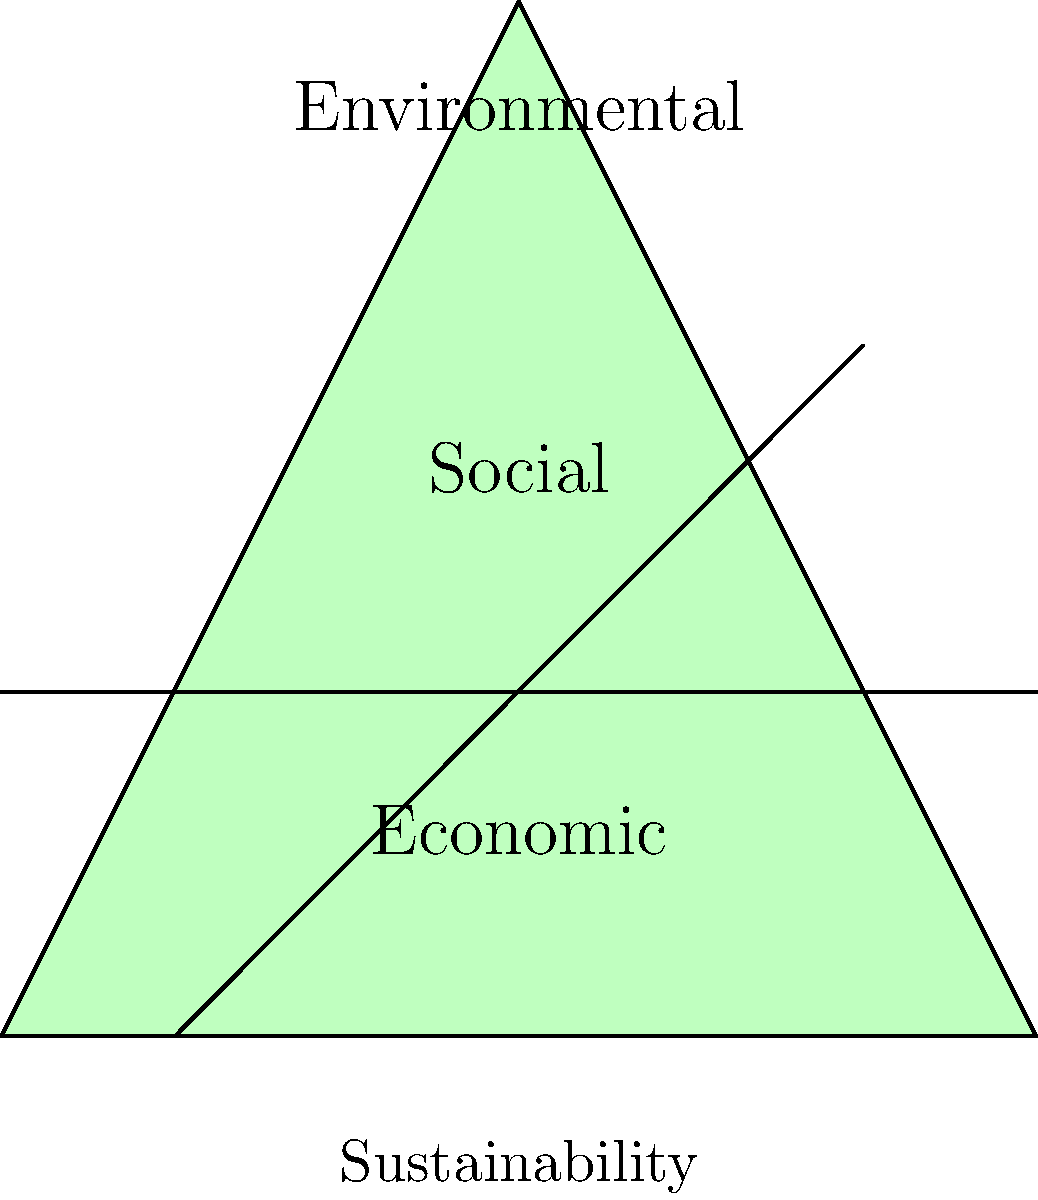In the context of sustainable development, which component of the sustainability triangle is most closely aligned with Maslow's hierarchy of needs, and why might this alignment be significant for promoting sustainable practices? To answer this question, let's consider the following steps:

1. Understand the components of the sustainability triangle:
   - Environmental: Focuses on protecting ecosystems and natural resources
   - Social: Deals with human well-being, education, and equality
   - Economic: Concerns financial stability and growth

2. Recall Maslow's hierarchy of needs:
   - Physiological needs (food, water, shelter)
   - Safety needs (security, stability)
   - Social needs (love, belonging)
   - Esteem needs (recognition, respect)
   - Self-actualization (personal growth, fulfillment)

3. Analyze the alignment:
   - The social component of sustainability most closely aligns with Maslow's hierarchy, as it directly addresses human well-being and social needs.

4. Consider the significance:
   - This alignment is important because it suggests that meeting basic human needs is a prerequisite for promoting sustainable practices.
   - As individuals progress through Maslow's hierarchy, they may become more capable of and interested in engaging with environmental and economic aspects of sustainability.

5. Implications for sustainable practices:
   - Addressing social sustainability may create a foundation for broader sustainability efforts.
   - People whose basic needs are met are more likely to consider long-term environmental and economic sustainability.
Answer: Social component; enables progression through Maslow's hierarchy, fostering broader sustainability engagement. 